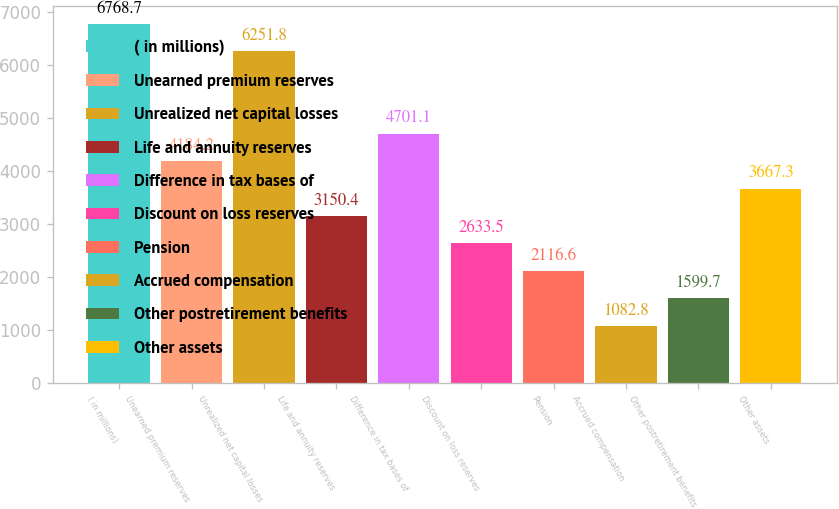Convert chart to OTSL. <chart><loc_0><loc_0><loc_500><loc_500><bar_chart><fcel>( in millions)<fcel>Unearned premium reserves<fcel>Unrealized net capital losses<fcel>Life and annuity reserves<fcel>Difference in tax bases of<fcel>Discount on loss reserves<fcel>Pension<fcel>Accrued compensation<fcel>Other postretirement benefits<fcel>Other assets<nl><fcel>6768.7<fcel>4184.2<fcel>6251.8<fcel>3150.4<fcel>4701.1<fcel>2633.5<fcel>2116.6<fcel>1082.8<fcel>1599.7<fcel>3667.3<nl></chart> 